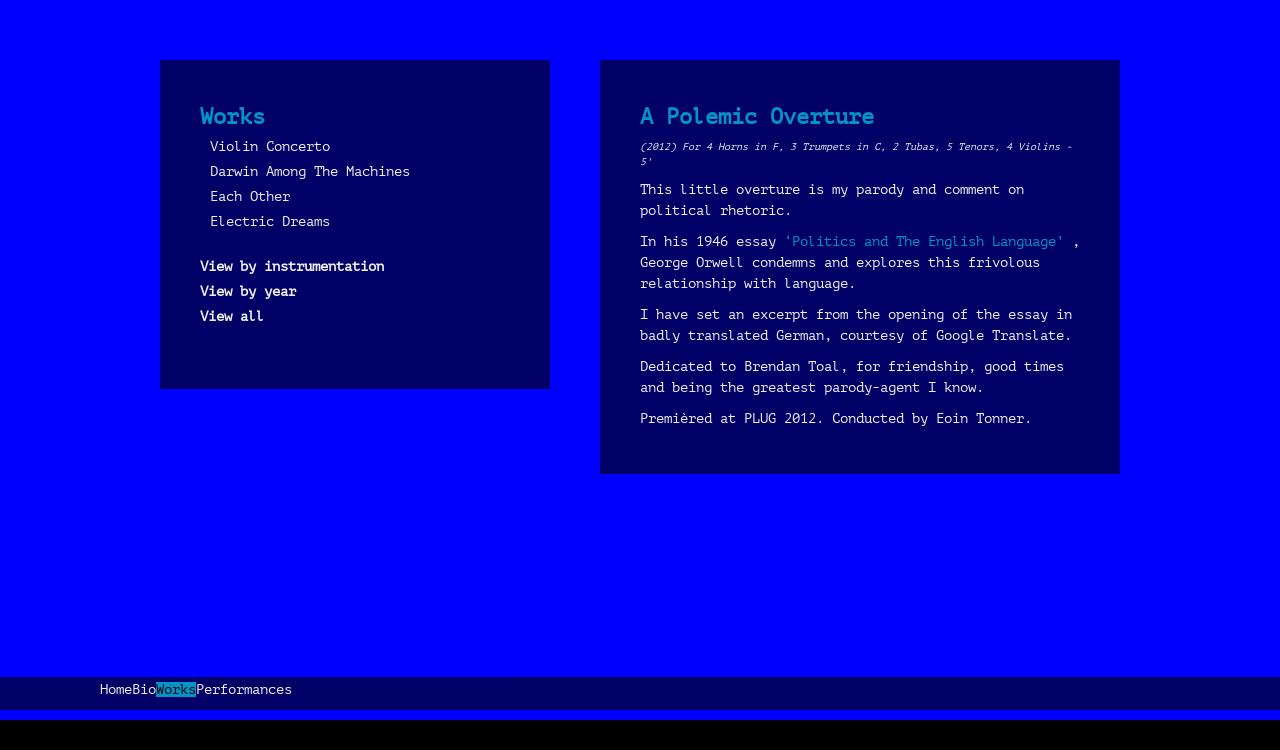Could you guide me through the process of developing this website with HTML? To develop a website like the one shown in the image using HTML, start by structuring the main components such as the header with navigation links, and the two main content sections. Use a simple HTML structure with div elements for each section, style them with CSS to match the layout and colors visible in the image. Add CSS classes to manage the layout of the 'Works' and 'A Polemic Overture' sections. Moreover, integrate responsive design elements to ensure that the website adapts to various screen sizes. 